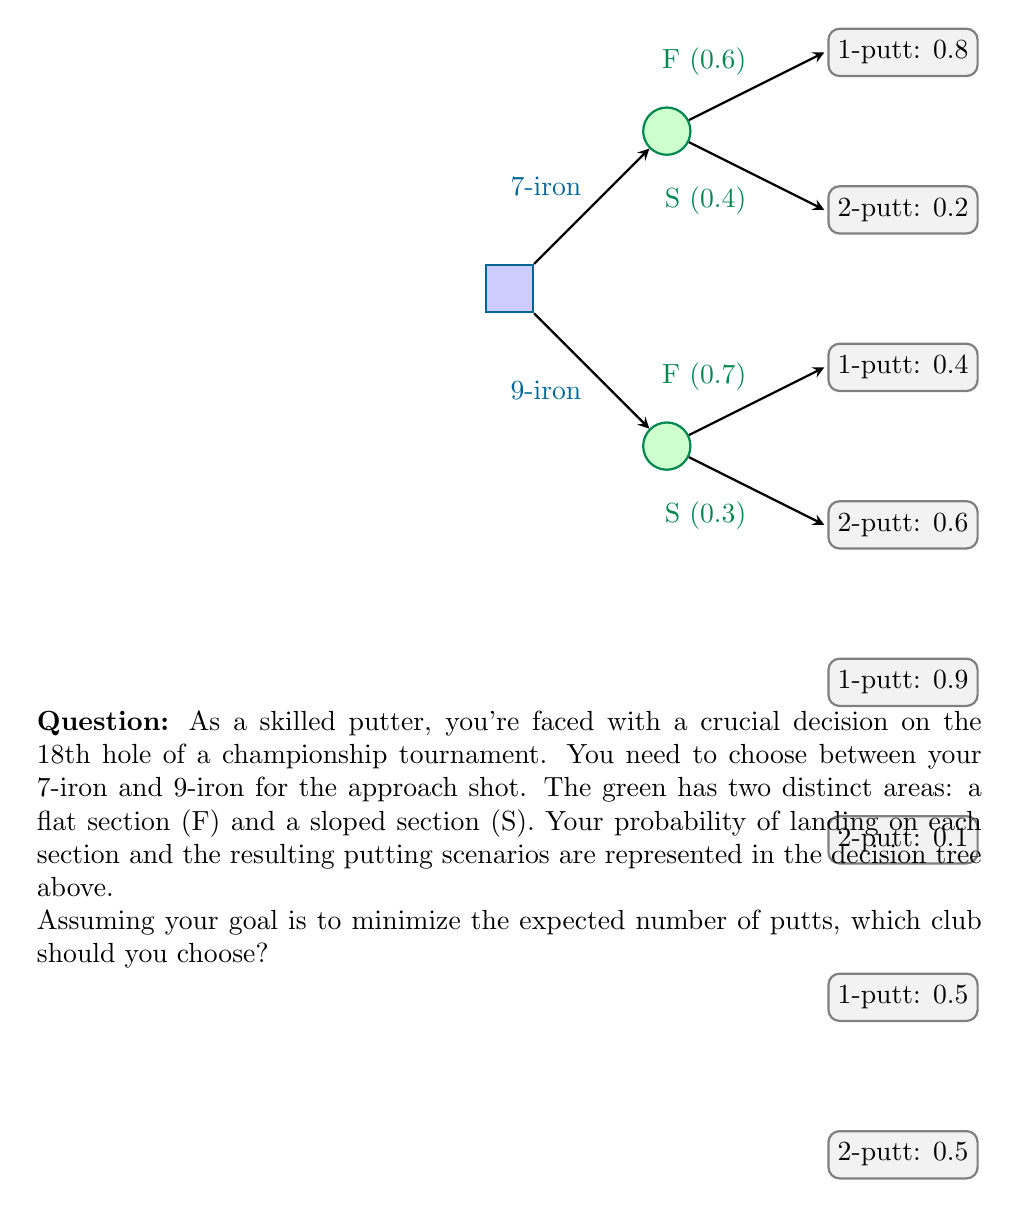Provide a solution to this math problem. Let's solve this problem using decision tree analysis:

1) First, calculate the expected number of putts for each scenario:

   For 7-iron:
   - Flat section (F):
     $E(\text{putts}|F) = 1 \times 0.8 + 2 \times 0.2 = 1.2$
   - Sloped section (S):
     $E(\text{putts}|S) = 1 \times 0.4 + 2 \times 0.6 = 1.6$

   For 9-iron:
   - Flat section (F):
     $E(\text{putts}|F) = 1 \times 0.9 + 2 \times 0.1 = 1.1$
   - Sloped section (S):
     $E(\text{putts}|S) = 1 \times 0.5 + 2 \times 0.5 = 1.5$

2) Now, calculate the overall expected number of putts for each club:

   For 7-iron:
   $E(\text{putts}_7) = 0.6 \times 1.2 + 0.4 \times 1.6 = 0.72 + 0.64 = 1.36$

   For 9-iron:
   $E(\text{putts}_9) = 0.7 \times 1.1 + 0.3 \times 1.5 = 0.77 + 0.45 = 1.22$

3) Compare the expected number of putts:

   The 9-iron has a lower expected number of putts (1.22) compared to the 7-iron (1.36).

Therefore, to minimize the expected number of putts, you should choose the 9-iron.
Answer: 9-iron 